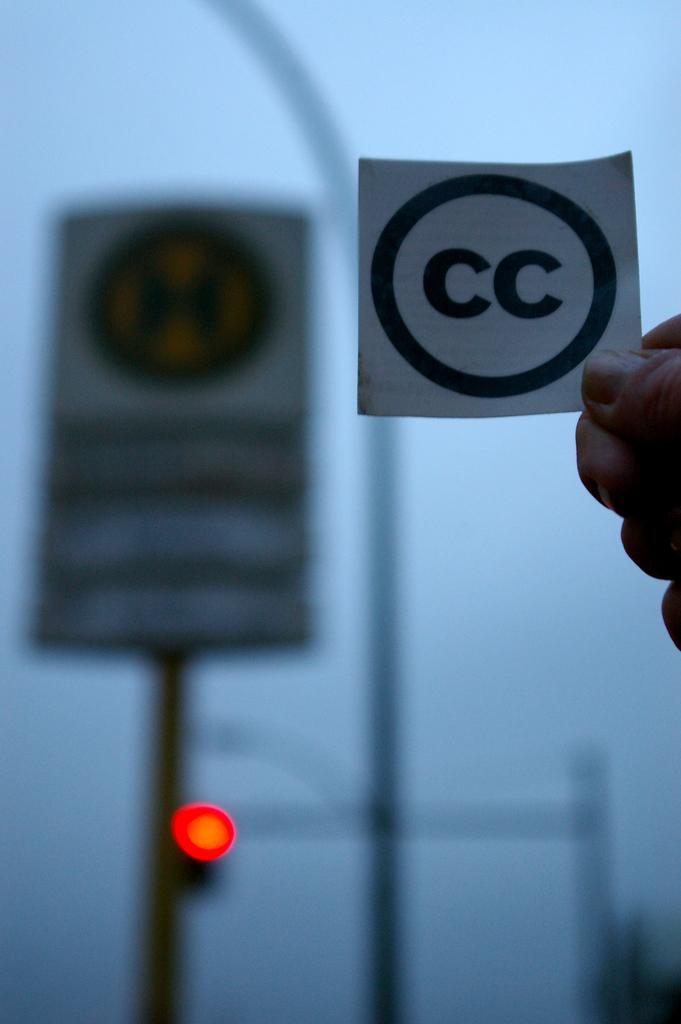Could you give a brief overview of what you see in this image? In this image we can see one person's hand holding a white card with text, one board with pole, one red light, two poles, one object on the bottom right side of the image in the background, it looks like the sky in the background and the background is blurred. 